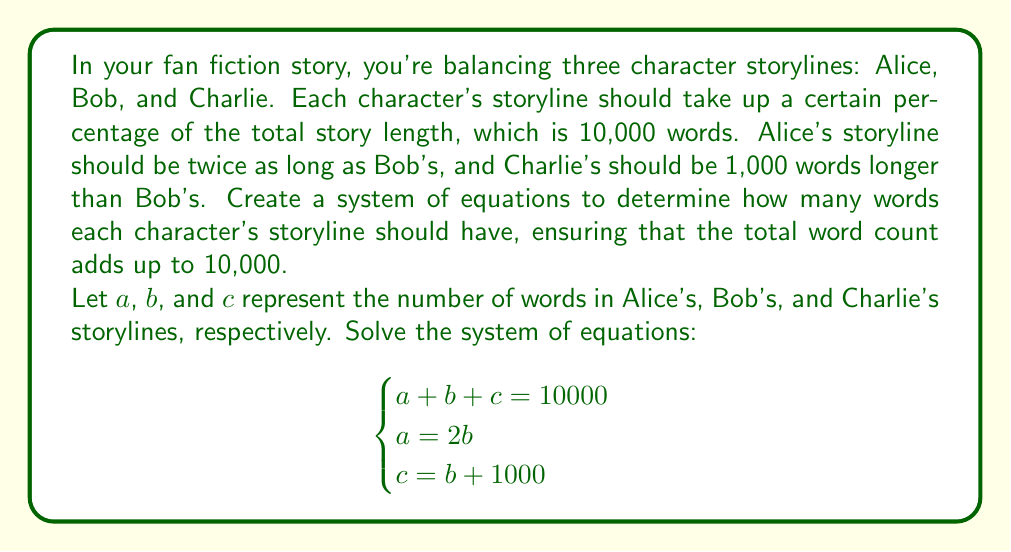Could you help me with this problem? Let's solve this system of equations step by step:

1) We have three equations:
   $$\begin{cases}
   a + b + c = 10000 \quad (1)\\
   a = 2b \quad (2)\\
   c = b + 1000 \quad (3)
   \end{cases}$$

2) From equation (2), we can substitute $a$ with $2b$ in equation (1):
   $2b + b + c = 10000$
   $3b + c = 10000 \quad (4)$

3) Now, let's substitute $c$ from equation (3) into equation (4):
   $3b + (b + 1000) = 10000$
   $4b + 1000 = 10000$

4) Solve for $b$:
   $4b = 9000$
   $b = 2250$

5) Now that we know $b$, we can find $a$ using equation (2):
   $a = 2b = 2(2250) = 4500$

6) And we can find $c$ using equation (3):
   $c = b + 1000 = 2250 + 1000 = 3250$

7) Let's verify that these values satisfy the original equation (1):
   $a + b + c = 4500 + 2250 + 3250 = 10000$

Therefore, the solution is:
Alice's storyline (a): 4500 words
Bob's storyline (b): 2250 words
Charlie's storyline (c): 3250 words
Answer: Alice's storyline: 4500 words
Bob's storyline: 2250 words
Charlie's storyline: 3250 words 